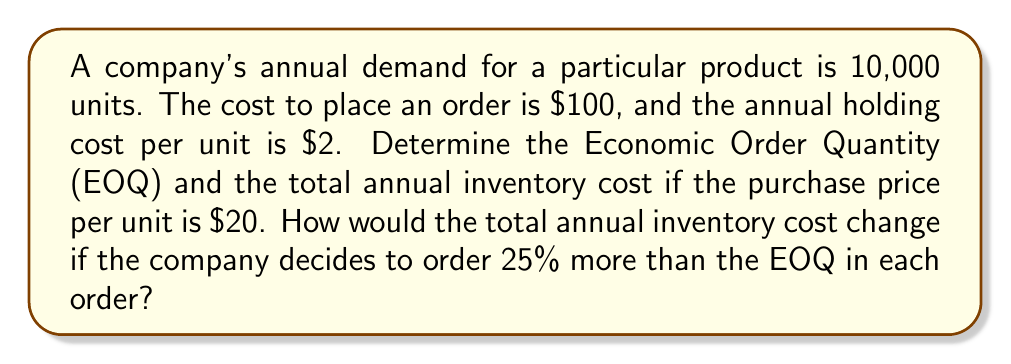Help me with this question. To solve this problem, we'll use the Economic Order Quantity (EOQ) model and follow these steps:

1. Calculate the EOQ:
   The EOQ formula is: $$ EOQ = \sqrt{\frac{2DS}{H}} $$
   Where:
   $D$ = Annual demand
   $S$ = Ordering cost per order
   $H$ = Annual holding cost per unit

   Plugging in the values:
   $$ EOQ = \sqrt{\frac{2 \times 10,000 \times 100}{2}} = 1,000 \text{ units} $$

2. Calculate the total annual inventory cost:
   Total cost = Purchase cost + Ordering cost + Holding cost
   $$ TC = PD + \frac{D}{Q}S + \frac{Q}{2}H $$
   Where:
   $P$ = Purchase price per unit
   $Q$ = Order quantity (EOQ in this case)

   $$ TC = 20 \times 10,000 + \frac{10,000}{1,000} \times 100 + \frac{1,000}{2} \times 2 $$
   $$ TC = 200,000 + 1,000 + 1,000 = 202,000 $$

3. Calculate the new order quantity (25% more than EOQ):
   New Q = 1,000 × 1.25 = 1,250 units

4. Calculate the new total annual inventory cost:
   $$ TC_{new} = 20 \times 10,000 + \frac{10,000}{1,250} \times 100 + \frac{1,250}{2} \times 2 $$
   $$ TC_{new} = 200,000 + 800 + 1,250 = 202,050 $$

5. Calculate the difference in total annual inventory cost:
   Difference = $202,050 - $202,000 = $50

The total annual inventory cost increases by $50 when ordering 25% more than the EOQ.
Answer: The Economic Order Quantity (EOQ) is 1,000 units. The total annual inventory cost at EOQ is $202,000. When ordering 25% more than the EOQ, the total annual inventory cost increases to $202,050, which is a $50 increase. 